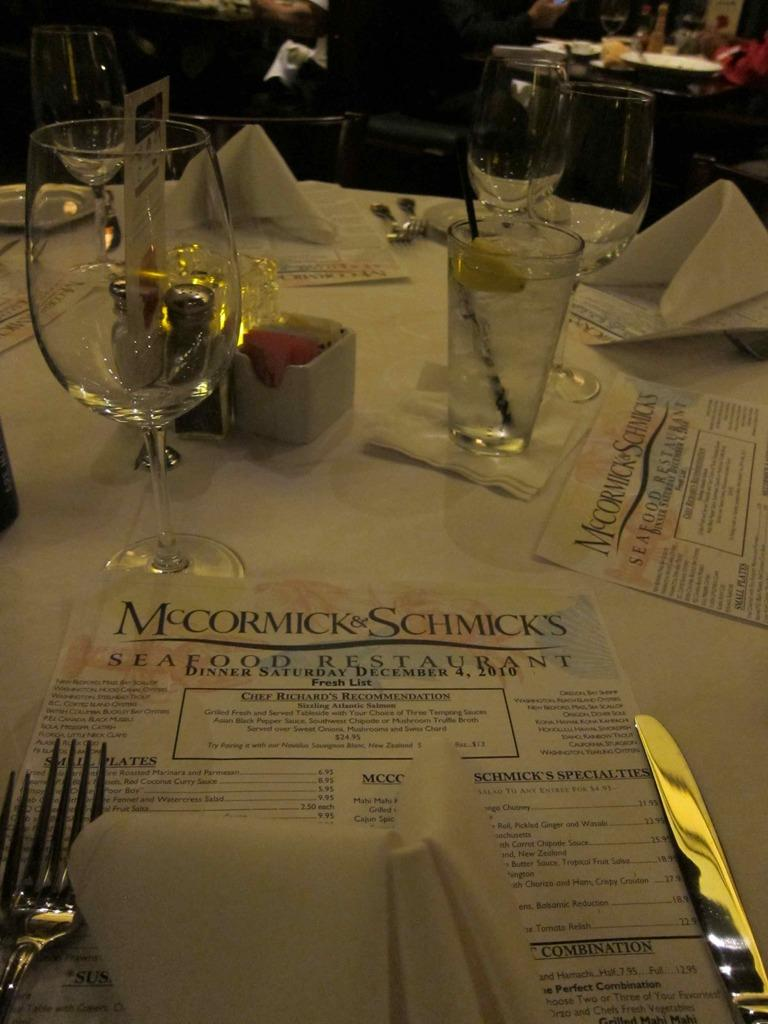What piece of furniture is present in the image? There is a table in the image. What items are placed on the table? There are papers, a knife, a fork, glasses, and tissue papers on the table. What type of utensils can be seen on the table? There is a knife and a fork on the table. What is used for drinking in the image? There are glasses on the table for drinking. What can be used for cleaning or wiping in the image? Tissue papers are present on the table for cleaning or wiping. What type of plants can be seen growing on the table in the image? There are no plants visible on the table in the image. 